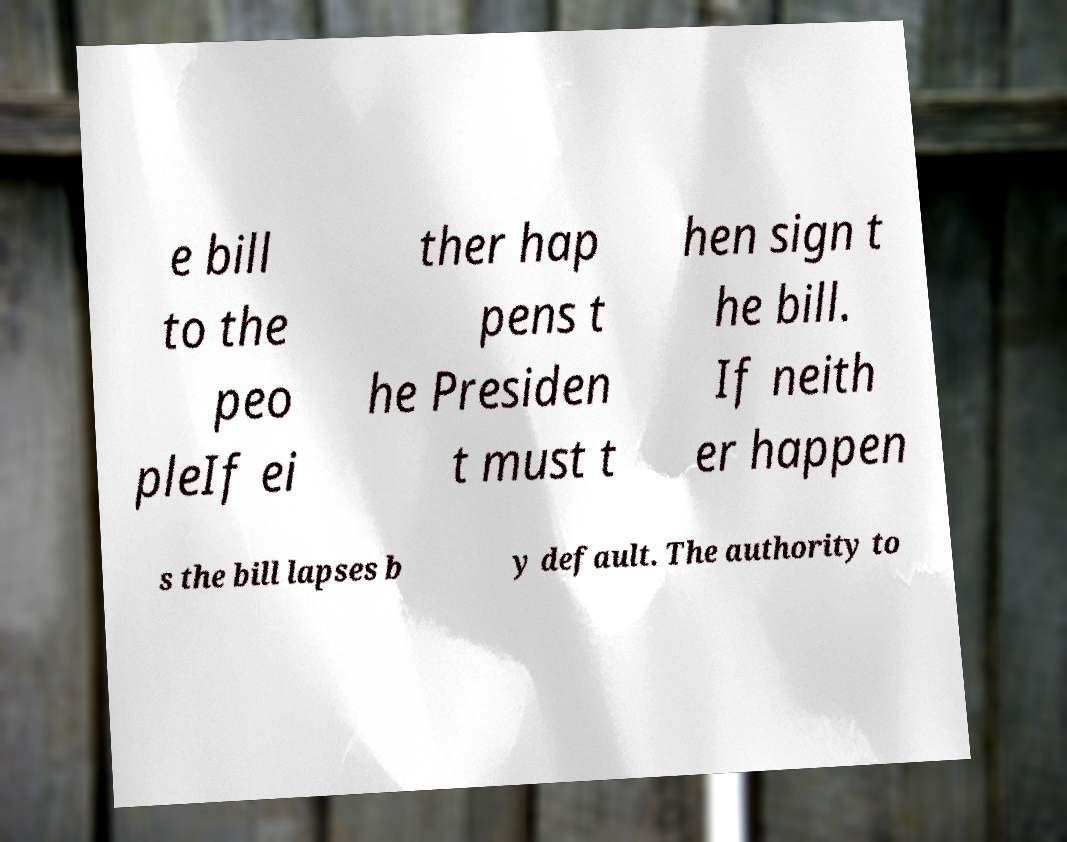Could you extract and type out the text from this image? e bill to the peo pleIf ei ther hap pens t he Presiden t must t hen sign t he bill. If neith er happen s the bill lapses b y default. The authority to 